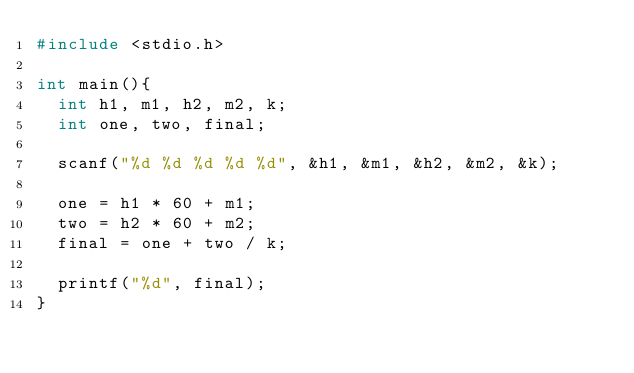<code> <loc_0><loc_0><loc_500><loc_500><_C_>#include <stdio.h>

int main(){
	int h1, m1, h2, m2, k;
	int one, two, final;
	
	scanf("%d %d %d %d %d", &h1, &m1, &h2, &m2, &k);
	
	one = h1 * 60 + m1;
	two = h2 * 60 + m2;
	final = one + two / k;
	
	printf("%d", final);
}</code> 